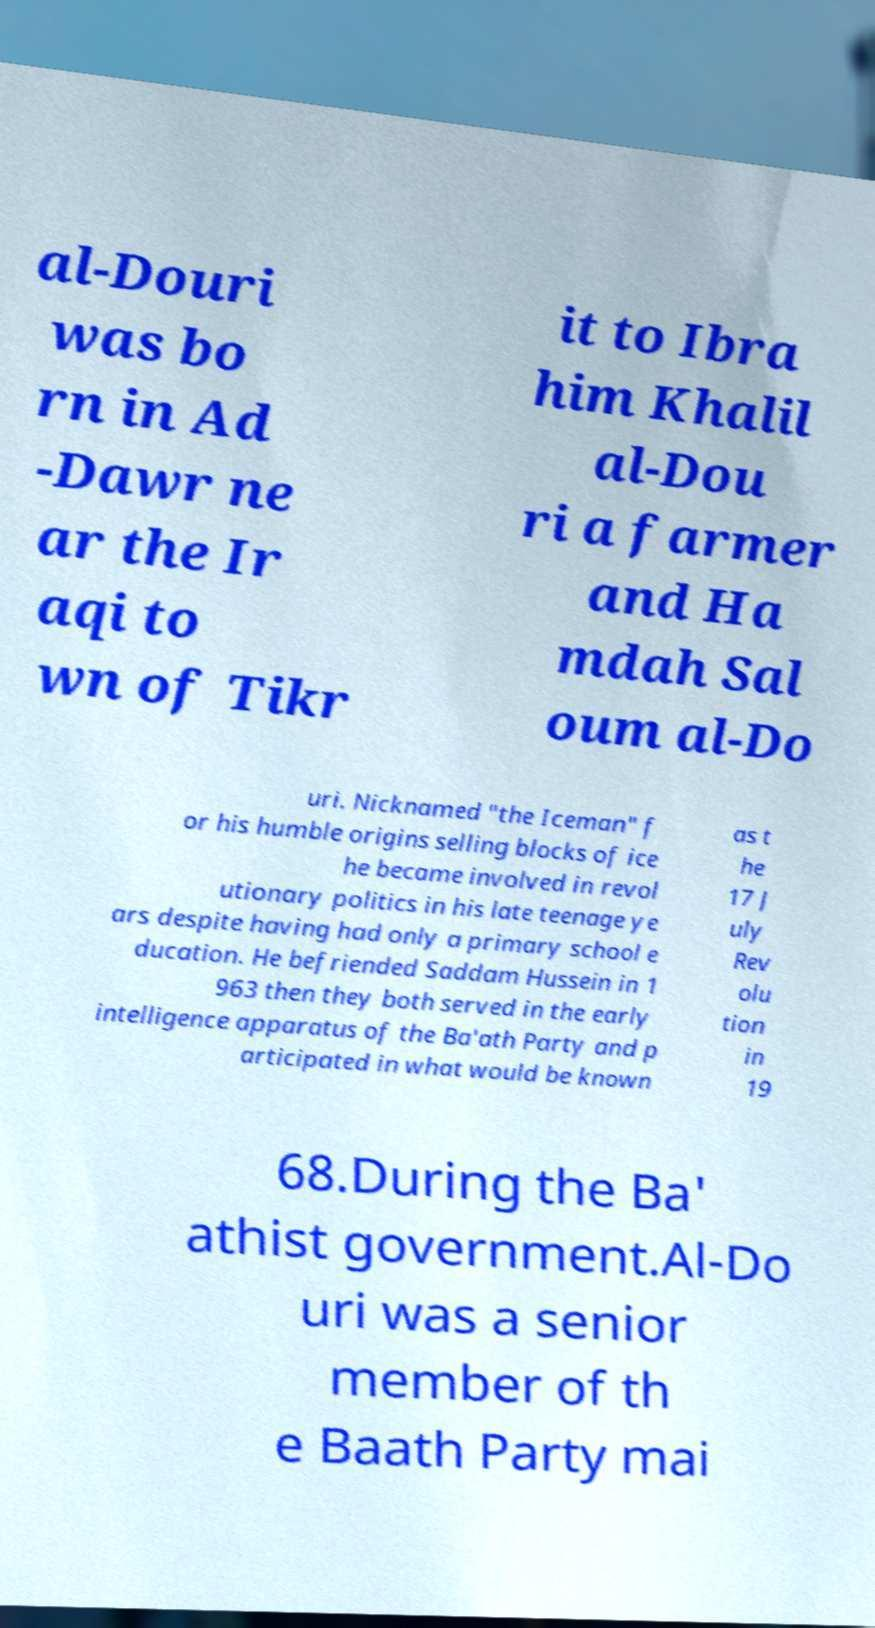Could you extract and type out the text from this image? al-Douri was bo rn in Ad -Dawr ne ar the Ir aqi to wn of Tikr it to Ibra him Khalil al-Dou ri a farmer and Ha mdah Sal oum al-Do uri. Nicknamed "the Iceman" f or his humble origins selling blocks of ice he became involved in revol utionary politics in his late teenage ye ars despite having had only a primary school e ducation. He befriended Saddam Hussein in 1 963 then they both served in the early intelligence apparatus of the Ba'ath Party and p articipated in what would be known as t he 17 J uly Rev olu tion in 19 68.During the Ba' athist government.Al-Do uri was a senior member of th e Baath Party mai 